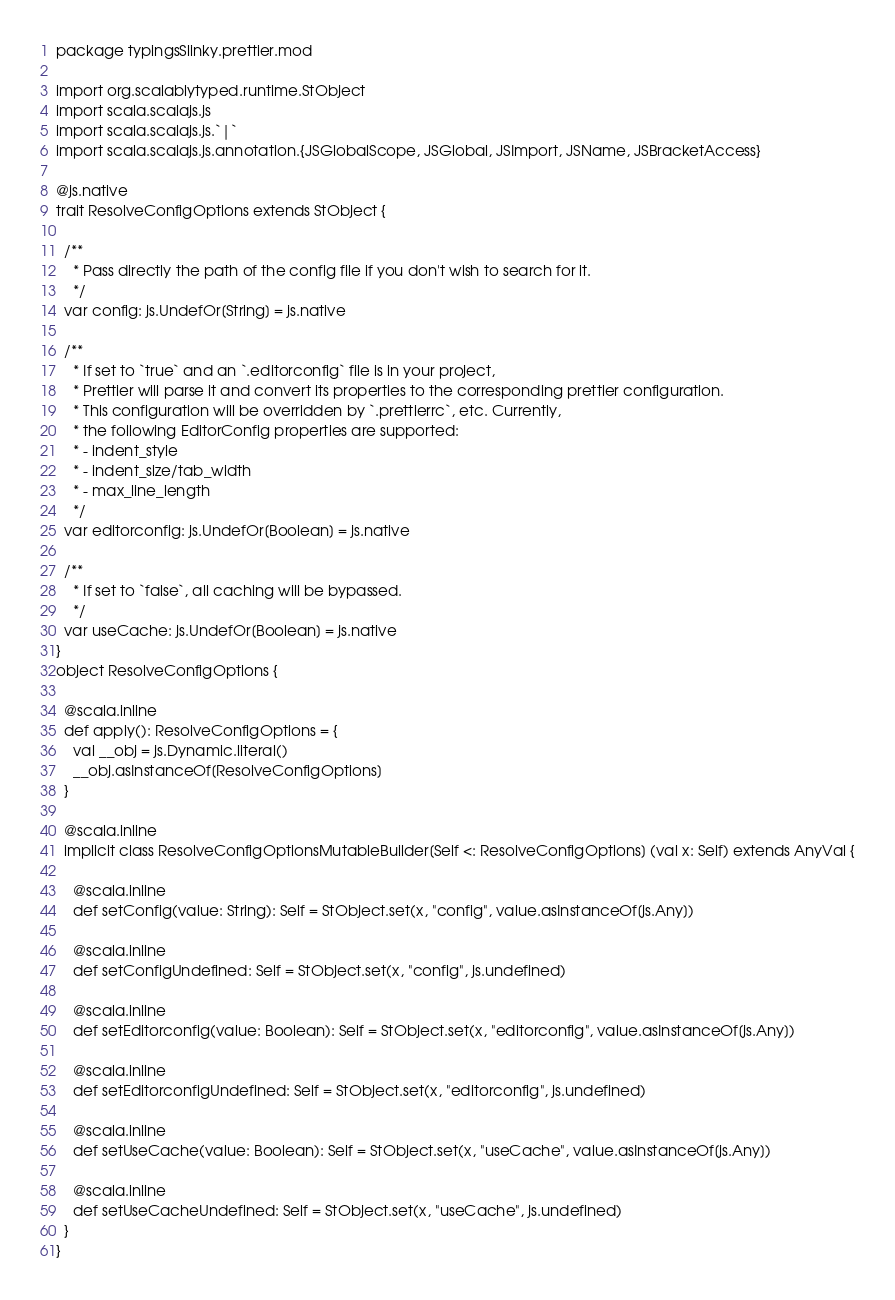Convert code to text. <code><loc_0><loc_0><loc_500><loc_500><_Scala_>package typingsSlinky.prettier.mod

import org.scalablytyped.runtime.StObject
import scala.scalajs.js
import scala.scalajs.js.`|`
import scala.scalajs.js.annotation.{JSGlobalScope, JSGlobal, JSImport, JSName, JSBracketAccess}

@js.native
trait ResolveConfigOptions extends StObject {
  
  /**
    * Pass directly the path of the config file if you don't wish to search for it.
    */
  var config: js.UndefOr[String] = js.native
  
  /**
    * If set to `true` and an `.editorconfig` file is in your project,
    * Prettier will parse it and convert its properties to the corresponding prettier configuration.
    * This configuration will be overridden by `.prettierrc`, etc. Currently,
    * the following EditorConfig properties are supported:
    * - indent_style
    * - indent_size/tab_width
    * - max_line_length
    */
  var editorconfig: js.UndefOr[Boolean] = js.native
  
  /**
    * If set to `false`, all caching will be bypassed.
    */
  var useCache: js.UndefOr[Boolean] = js.native
}
object ResolveConfigOptions {
  
  @scala.inline
  def apply(): ResolveConfigOptions = {
    val __obj = js.Dynamic.literal()
    __obj.asInstanceOf[ResolveConfigOptions]
  }
  
  @scala.inline
  implicit class ResolveConfigOptionsMutableBuilder[Self <: ResolveConfigOptions] (val x: Self) extends AnyVal {
    
    @scala.inline
    def setConfig(value: String): Self = StObject.set(x, "config", value.asInstanceOf[js.Any])
    
    @scala.inline
    def setConfigUndefined: Self = StObject.set(x, "config", js.undefined)
    
    @scala.inline
    def setEditorconfig(value: Boolean): Self = StObject.set(x, "editorconfig", value.asInstanceOf[js.Any])
    
    @scala.inline
    def setEditorconfigUndefined: Self = StObject.set(x, "editorconfig", js.undefined)
    
    @scala.inline
    def setUseCache(value: Boolean): Self = StObject.set(x, "useCache", value.asInstanceOf[js.Any])
    
    @scala.inline
    def setUseCacheUndefined: Self = StObject.set(x, "useCache", js.undefined)
  }
}
</code> 